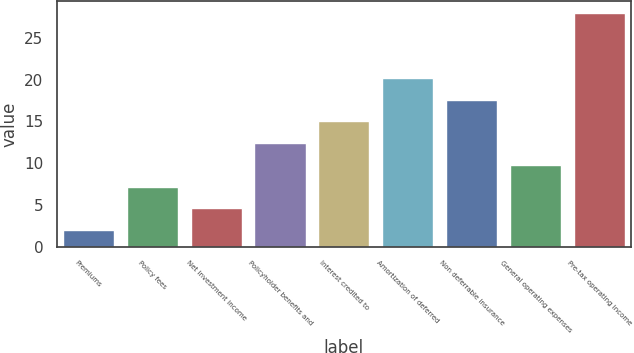<chart> <loc_0><loc_0><loc_500><loc_500><bar_chart><fcel>Premiums<fcel>Policy fees<fcel>Net investment income<fcel>Policyholder benefits and<fcel>Interest credited to<fcel>Amortization of deferred<fcel>Non deferrable insurance<fcel>General operating expenses<fcel>Pre-tax operating income<nl><fcel>2<fcel>7.2<fcel>4.6<fcel>12.4<fcel>15<fcel>20.2<fcel>17.6<fcel>9.8<fcel>28<nl></chart> 